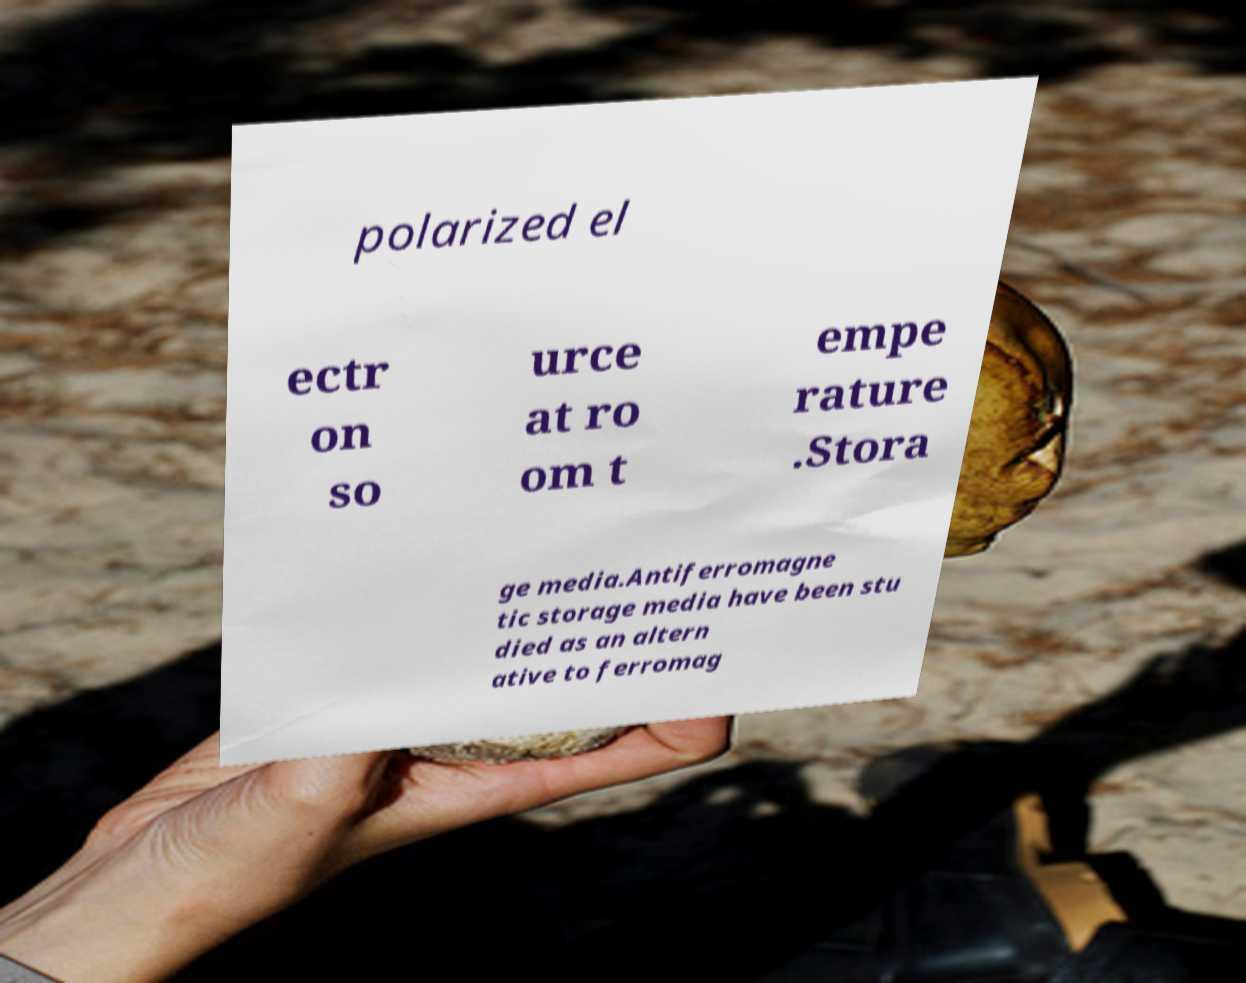Could you extract and type out the text from this image? polarized el ectr on so urce at ro om t empe rature .Stora ge media.Antiferromagne tic storage media have been stu died as an altern ative to ferromag 